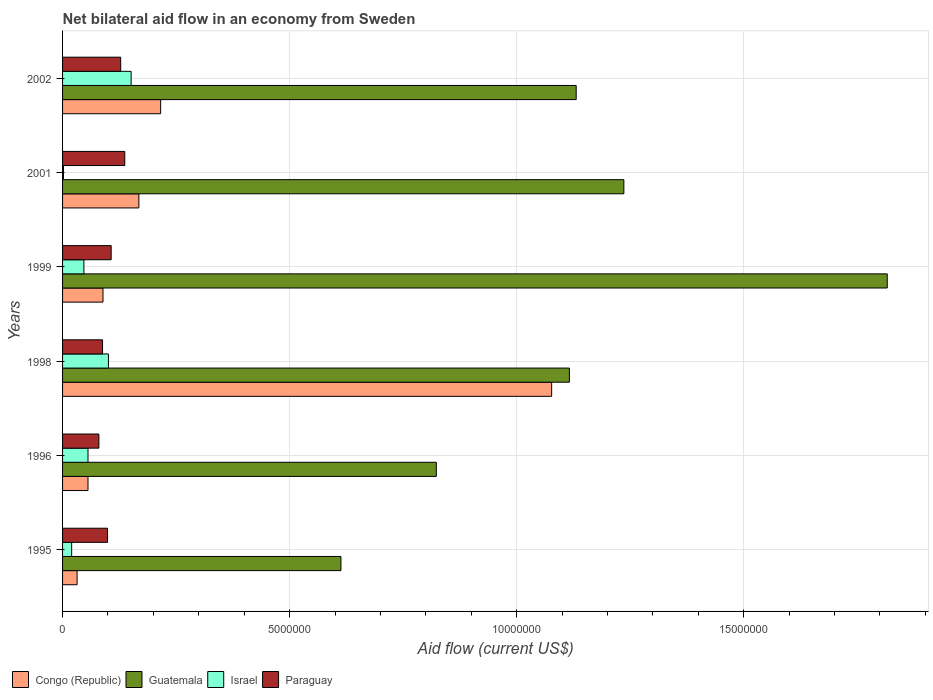How many different coloured bars are there?
Offer a terse response. 4. How many groups of bars are there?
Provide a succinct answer. 6. Are the number of bars per tick equal to the number of legend labels?
Offer a very short reply. Yes. How many bars are there on the 2nd tick from the top?
Offer a terse response. 4. What is the label of the 4th group of bars from the top?
Ensure brevity in your answer.  1998. What is the net bilateral aid flow in Guatemala in 2002?
Your answer should be compact. 1.13e+07. Across all years, what is the maximum net bilateral aid flow in Israel?
Provide a succinct answer. 1.51e+06. Across all years, what is the minimum net bilateral aid flow in Guatemala?
Your answer should be compact. 6.13e+06. In which year was the net bilateral aid flow in Guatemala minimum?
Your answer should be very brief. 1995. What is the total net bilateral aid flow in Guatemala in the graph?
Ensure brevity in your answer.  6.74e+07. What is the difference between the net bilateral aid flow in Paraguay in 1995 and that in 1999?
Your response must be concise. -8.00e+04. What is the difference between the net bilateral aid flow in Israel in 2001 and the net bilateral aid flow in Paraguay in 2002?
Make the answer very short. -1.26e+06. What is the average net bilateral aid flow in Paraguay per year?
Provide a succinct answer. 1.06e+06. In the year 1996, what is the difference between the net bilateral aid flow in Congo (Republic) and net bilateral aid flow in Guatemala?
Ensure brevity in your answer.  -7.67e+06. In how many years, is the net bilateral aid flow in Guatemala greater than 2000000 US$?
Provide a short and direct response. 6. What is the ratio of the net bilateral aid flow in Paraguay in 1998 to that in 2002?
Offer a terse response. 0.69. What is the difference between the highest and the second highest net bilateral aid flow in Paraguay?
Your answer should be very brief. 9.00e+04. What is the difference between the highest and the lowest net bilateral aid flow in Congo (Republic)?
Ensure brevity in your answer.  1.04e+07. In how many years, is the net bilateral aid flow in Israel greater than the average net bilateral aid flow in Israel taken over all years?
Your response must be concise. 2. Is the sum of the net bilateral aid flow in Paraguay in 1998 and 2002 greater than the maximum net bilateral aid flow in Congo (Republic) across all years?
Make the answer very short. No. What does the 4th bar from the top in 2002 represents?
Give a very brief answer. Congo (Republic). Are all the bars in the graph horizontal?
Provide a succinct answer. Yes. How many years are there in the graph?
Give a very brief answer. 6. What is the difference between two consecutive major ticks on the X-axis?
Provide a succinct answer. 5.00e+06. How many legend labels are there?
Make the answer very short. 4. How are the legend labels stacked?
Offer a terse response. Horizontal. What is the title of the graph?
Make the answer very short. Net bilateral aid flow in an economy from Sweden. Does "Puerto Rico" appear as one of the legend labels in the graph?
Offer a terse response. No. What is the label or title of the X-axis?
Offer a terse response. Aid flow (current US$). What is the label or title of the Y-axis?
Make the answer very short. Years. What is the Aid flow (current US$) in Guatemala in 1995?
Provide a succinct answer. 6.13e+06. What is the Aid flow (current US$) in Israel in 1995?
Keep it short and to the point. 2.00e+05. What is the Aid flow (current US$) in Paraguay in 1995?
Ensure brevity in your answer.  9.90e+05. What is the Aid flow (current US$) of Congo (Republic) in 1996?
Your response must be concise. 5.60e+05. What is the Aid flow (current US$) of Guatemala in 1996?
Your response must be concise. 8.23e+06. What is the Aid flow (current US$) in Israel in 1996?
Provide a short and direct response. 5.60e+05. What is the Aid flow (current US$) of Congo (Republic) in 1998?
Offer a terse response. 1.08e+07. What is the Aid flow (current US$) of Guatemala in 1998?
Make the answer very short. 1.12e+07. What is the Aid flow (current US$) in Israel in 1998?
Give a very brief answer. 1.01e+06. What is the Aid flow (current US$) in Paraguay in 1998?
Give a very brief answer. 8.80e+05. What is the Aid flow (current US$) in Congo (Republic) in 1999?
Keep it short and to the point. 8.90e+05. What is the Aid flow (current US$) in Guatemala in 1999?
Your response must be concise. 1.82e+07. What is the Aid flow (current US$) in Paraguay in 1999?
Offer a terse response. 1.07e+06. What is the Aid flow (current US$) in Congo (Republic) in 2001?
Ensure brevity in your answer.  1.68e+06. What is the Aid flow (current US$) of Guatemala in 2001?
Give a very brief answer. 1.24e+07. What is the Aid flow (current US$) in Paraguay in 2001?
Your response must be concise. 1.37e+06. What is the Aid flow (current US$) of Congo (Republic) in 2002?
Your response must be concise. 2.16e+06. What is the Aid flow (current US$) of Guatemala in 2002?
Your answer should be compact. 1.13e+07. What is the Aid flow (current US$) in Israel in 2002?
Your answer should be very brief. 1.51e+06. What is the Aid flow (current US$) of Paraguay in 2002?
Give a very brief answer. 1.28e+06. Across all years, what is the maximum Aid flow (current US$) in Congo (Republic)?
Provide a short and direct response. 1.08e+07. Across all years, what is the maximum Aid flow (current US$) of Guatemala?
Give a very brief answer. 1.82e+07. Across all years, what is the maximum Aid flow (current US$) in Israel?
Offer a terse response. 1.51e+06. Across all years, what is the maximum Aid flow (current US$) of Paraguay?
Provide a short and direct response. 1.37e+06. Across all years, what is the minimum Aid flow (current US$) in Congo (Republic)?
Give a very brief answer. 3.20e+05. Across all years, what is the minimum Aid flow (current US$) of Guatemala?
Your answer should be very brief. 6.13e+06. Across all years, what is the minimum Aid flow (current US$) of Israel?
Make the answer very short. 2.00e+04. What is the total Aid flow (current US$) in Congo (Republic) in the graph?
Give a very brief answer. 1.64e+07. What is the total Aid flow (current US$) of Guatemala in the graph?
Provide a short and direct response. 6.74e+07. What is the total Aid flow (current US$) in Israel in the graph?
Provide a short and direct response. 3.77e+06. What is the total Aid flow (current US$) in Paraguay in the graph?
Give a very brief answer. 6.39e+06. What is the difference between the Aid flow (current US$) in Guatemala in 1995 and that in 1996?
Provide a succinct answer. -2.10e+06. What is the difference between the Aid flow (current US$) in Israel in 1995 and that in 1996?
Offer a terse response. -3.60e+05. What is the difference between the Aid flow (current US$) in Congo (Republic) in 1995 and that in 1998?
Your response must be concise. -1.04e+07. What is the difference between the Aid flow (current US$) of Guatemala in 1995 and that in 1998?
Ensure brevity in your answer.  -5.03e+06. What is the difference between the Aid flow (current US$) of Israel in 1995 and that in 1998?
Make the answer very short. -8.10e+05. What is the difference between the Aid flow (current US$) of Congo (Republic) in 1995 and that in 1999?
Offer a very short reply. -5.70e+05. What is the difference between the Aid flow (current US$) in Guatemala in 1995 and that in 1999?
Give a very brief answer. -1.20e+07. What is the difference between the Aid flow (current US$) of Israel in 1995 and that in 1999?
Your response must be concise. -2.70e+05. What is the difference between the Aid flow (current US$) of Paraguay in 1995 and that in 1999?
Provide a short and direct response. -8.00e+04. What is the difference between the Aid flow (current US$) in Congo (Republic) in 1995 and that in 2001?
Keep it short and to the point. -1.36e+06. What is the difference between the Aid flow (current US$) of Guatemala in 1995 and that in 2001?
Your answer should be very brief. -6.23e+06. What is the difference between the Aid flow (current US$) of Paraguay in 1995 and that in 2001?
Offer a terse response. -3.80e+05. What is the difference between the Aid flow (current US$) of Congo (Republic) in 1995 and that in 2002?
Your answer should be compact. -1.84e+06. What is the difference between the Aid flow (current US$) of Guatemala in 1995 and that in 2002?
Offer a terse response. -5.18e+06. What is the difference between the Aid flow (current US$) in Israel in 1995 and that in 2002?
Make the answer very short. -1.31e+06. What is the difference between the Aid flow (current US$) of Congo (Republic) in 1996 and that in 1998?
Offer a very short reply. -1.02e+07. What is the difference between the Aid flow (current US$) of Guatemala in 1996 and that in 1998?
Keep it short and to the point. -2.93e+06. What is the difference between the Aid flow (current US$) of Israel in 1996 and that in 1998?
Offer a terse response. -4.50e+05. What is the difference between the Aid flow (current US$) of Congo (Republic) in 1996 and that in 1999?
Give a very brief answer. -3.30e+05. What is the difference between the Aid flow (current US$) in Guatemala in 1996 and that in 1999?
Keep it short and to the point. -9.93e+06. What is the difference between the Aid flow (current US$) in Paraguay in 1996 and that in 1999?
Give a very brief answer. -2.70e+05. What is the difference between the Aid flow (current US$) of Congo (Republic) in 1996 and that in 2001?
Give a very brief answer. -1.12e+06. What is the difference between the Aid flow (current US$) in Guatemala in 1996 and that in 2001?
Your response must be concise. -4.13e+06. What is the difference between the Aid flow (current US$) of Israel in 1996 and that in 2001?
Your response must be concise. 5.40e+05. What is the difference between the Aid flow (current US$) of Paraguay in 1996 and that in 2001?
Ensure brevity in your answer.  -5.70e+05. What is the difference between the Aid flow (current US$) in Congo (Republic) in 1996 and that in 2002?
Make the answer very short. -1.60e+06. What is the difference between the Aid flow (current US$) in Guatemala in 1996 and that in 2002?
Your answer should be compact. -3.08e+06. What is the difference between the Aid flow (current US$) in Israel in 1996 and that in 2002?
Make the answer very short. -9.50e+05. What is the difference between the Aid flow (current US$) of Paraguay in 1996 and that in 2002?
Offer a very short reply. -4.80e+05. What is the difference between the Aid flow (current US$) in Congo (Republic) in 1998 and that in 1999?
Give a very brief answer. 9.88e+06. What is the difference between the Aid flow (current US$) of Guatemala in 1998 and that in 1999?
Ensure brevity in your answer.  -7.00e+06. What is the difference between the Aid flow (current US$) of Israel in 1998 and that in 1999?
Your response must be concise. 5.40e+05. What is the difference between the Aid flow (current US$) in Congo (Republic) in 1998 and that in 2001?
Make the answer very short. 9.09e+06. What is the difference between the Aid flow (current US$) of Guatemala in 1998 and that in 2001?
Ensure brevity in your answer.  -1.20e+06. What is the difference between the Aid flow (current US$) in Israel in 1998 and that in 2001?
Provide a succinct answer. 9.90e+05. What is the difference between the Aid flow (current US$) of Paraguay in 1998 and that in 2001?
Your response must be concise. -4.90e+05. What is the difference between the Aid flow (current US$) in Congo (Republic) in 1998 and that in 2002?
Provide a short and direct response. 8.61e+06. What is the difference between the Aid flow (current US$) of Israel in 1998 and that in 2002?
Offer a terse response. -5.00e+05. What is the difference between the Aid flow (current US$) in Paraguay in 1998 and that in 2002?
Offer a very short reply. -4.00e+05. What is the difference between the Aid flow (current US$) in Congo (Republic) in 1999 and that in 2001?
Offer a very short reply. -7.90e+05. What is the difference between the Aid flow (current US$) of Guatemala in 1999 and that in 2001?
Provide a short and direct response. 5.80e+06. What is the difference between the Aid flow (current US$) of Paraguay in 1999 and that in 2001?
Your answer should be very brief. -3.00e+05. What is the difference between the Aid flow (current US$) of Congo (Republic) in 1999 and that in 2002?
Keep it short and to the point. -1.27e+06. What is the difference between the Aid flow (current US$) in Guatemala in 1999 and that in 2002?
Provide a succinct answer. 6.85e+06. What is the difference between the Aid flow (current US$) in Israel in 1999 and that in 2002?
Your response must be concise. -1.04e+06. What is the difference between the Aid flow (current US$) in Paraguay in 1999 and that in 2002?
Offer a terse response. -2.10e+05. What is the difference between the Aid flow (current US$) in Congo (Republic) in 2001 and that in 2002?
Your response must be concise. -4.80e+05. What is the difference between the Aid flow (current US$) of Guatemala in 2001 and that in 2002?
Provide a short and direct response. 1.05e+06. What is the difference between the Aid flow (current US$) in Israel in 2001 and that in 2002?
Offer a very short reply. -1.49e+06. What is the difference between the Aid flow (current US$) of Paraguay in 2001 and that in 2002?
Keep it short and to the point. 9.00e+04. What is the difference between the Aid flow (current US$) of Congo (Republic) in 1995 and the Aid flow (current US$) of Guatemala in 1996?
Your response must be concise. -7.91e+06. What is the difference between the Aid flow (current US$) in Congo (Republic) in 1995 and the Aid flow (current US$) in Paraguay in 1996?
Your answer should be compact. -4.80e+05. What is the difference between the Aid flow (current US$) of Guatemala in 1995 and the Aid flow (current US$) of Israel in 1996?
Give a very brief answer. 5.57e+06. What is the difference between the Aid flow (current US$) in Guatemala in 1995 and the Aid flow (current US$) in Paraguay in 1996?
Offer a very short reply. 5.33e+06. What is the difference between the Aid flow (current US$) of Israel in 1995 and the Aid flow (current US$) of Paraguay in 1996?
Your answer should be compact. -6.00e+05. What is the difference between the Aid flow (current US$) of Congo (Republic) in 1995 and the Aid flow (current US$) of Guatemala in 1998?
Your response must be concise. -1.08e+07. What is the difference between the Aid flow (current US$) in Congo (Republic) in 1995 and the Aid flow (current US$) in Israel in 1998?
Your answer should be compact. -6.90e+05. What is the difference between the Aid flow (current US$) in Congo (Republic) in 1995 and the Aid flow (current US$) in Paraguay in 1998?
Offer a terse response. -5.60e+05. What is the difference between the Aid flow (current US$) in Guatemala in 1995 and the Aid flow (current US$) in Israel in 1998?
Make the answer very short. 5.12e+06. What is the difference between the Aid flow (current US$) of Guatemala in 1995 and the Aid flow (current US$) of Paraguay in 1998?
Your answer should be compact. 5.25e+06. What is the difference between the Aid flow (current US$) of Israel in 1995 and the Aid flow (current US$) of Paraguay in 1998?
Give a very brief answer. -6.80e+05. What is the difference between the Aid flow (current US$) in Congo (Republic) in 1995 and the Aid flow (current US$) in Guatemala in 1999?
Your response must be concise. -1.78e+07. What is the difference between the Aid flow (current US$) of Congo (Republic) in 1995 and the Aid flow (current US$) of Israel in 1999?
Your response must be concise. -1.50e+05. What is the difference between the Aid flow (current US$) of Congo (Republic) in 1995 and the Aid flow (current US$) of Paraguay in 1999?
Offer a very short reply. -7.50e+05. What is the difference between the Aid flow (current US$) of Guatemala in 1995 and the Aid flow (current US$) of Israel in 1999?
Make the answer very short. 5.66e+06. What is the difference between the Aid flow (current US$) of Guatemala in 1995 and the Aid flow (current US$) of Paraguay in 1999?
Keep it short and to the point. 5.06e+06. What is the difference between the Aid flow (current US$) of Israel in 1995 and the Aid flow (current US$) of Paraguay in 1999?
Your answer should be compact. -8.70e+05. What is the difference between the Aid flow (current US$) of Congo (Republic) in 1995 and the Aid flow (current US$) of Guatemala in 2001?
Offer a very short reply. -1.20e+07. What is the difference between the Aid flow (current US$) in Congo (Republic) in 1995 and the Aid flow (current US$) in Paraguay in 2001?
Make the answer very short. -1.05e+06. What is the difference between the Aid flow (current US$) in Guatemala in 1995 and the Aid flow (current US$) in Israel in 2001?
Your answer should be very brief. 6.11e+06. What is the difference between the Aid flow (current US$) in Guatemala in 1995 and the Aid flow (current US$) in Paraguay in 2001?
Your answer should be compact. 4.76e+06. What is the difference between the Aid flow (current US$) of Israel in 1995 and the Aid flow (current US$) of Paraguay in 2001?
Provide a succinct answer. -1.17e+06. What is the difference between the Aid flow (current US$) in Congo (Republic) in 1995 and the Aid flow (current US$) in Guatemala in 2002?
Give a very brief answer. -1.10e+07. What is the difference between the Aid flow (current US$) in Congo (Republic) in 1995 and the Aid flow (current US$) in Israel in 2002?
Offer a very short reply. -1.19e+06. What is the difference between the Aid flow (current US$) in Congo (Republic) in 1995 and the Aid flow (current US$) in Paraguay in 2002?
Give a very brief answer. -9.60e+05. What is the difference between the Aid flow (current US$) in Guatemala in 1995 and the Aid flow (current US$) in Israel in 2002?
Offer a terse response. 4.62e+06. What is the difference between the Aid flow (current US$) of Guatemala in 1995 and the Aid flow (current US$) of Paraguay in 2002?
Your answer should be compact. 4.85e+06. What is the difference between the Aid flow (current US$) in Israel in 1995 and the Aid flow (current US$) in Paraguay in 2002?
Provide a short and direct response. -1.08e+06. What is the difference between the Aid flow (current US$) in Congo (Republic) in 1996 and the Aid flow (current US$) in Guatemala in 1998?
Make the answer very short. -1.06e+07. What is the difference between the Aid flow (current US$) of Congo (Republic) in 1996 and the Aid flow (current US$) of Israel in 1998?
Provide a short and direct response. -4.50e+05. What is the difference between the Aid flow (current US$) of Congo (Republic) in 1996 and the Aid flow (current US$) of Paraguay in 1998?
Your response must be concise. -3.20e+05. What is the difference between the Aid flow (current US$) of Guatemala in 1996 and the Aid flow (current US$) of Israel in 1998?
Keep it short and to the point. 7.22e+06. What is the difference between the Aid flow (current US$) of Guatemala in 1996 and the Aid flow (current US$) of Paraguay in 1998?
Give a very brief answer. 7.35e+06. What is the difference between the Aid flow (current US$) in Israel in 1996 and the Aid flow (current US$) in Paraguay in 1998?
Your response must be concise. -3.20e+05. What is the difference between the Aid flow (current US$) in Congo (Republic) in 1996 and the Aid flow (current US$) in Guatemala in 1999?
Give a very brief answer. -1.76e+07. What is the difference between the Aid flow (current US$) in Congo (Republic) in 1996 and the Aid flow (current US$) in Paraguay in 1999?
Provide a short and direct response. -5.10e+05. What is the difference between the Aid flow (current US$) of Guatemala in 1996 and the Aid flow (current US$) of Israel in 1999?
Keep it short and to the point. 7.76e+06. What is the difference between the Aid flow (current US$) of Guatemala in 1996 and the Aid flow (current US$) of Paraguay in 1999?
Your response must be concise. 7.16e+06. What is the difference between the Aid flow (current US$) of Israel in 1996 and the Aid flow (current US$) of Paraguay in 1999?
Make the answer very short. -5.10e+05. What is the difference between the Aid flow (current US$) of Congo (Republic) in 1996 and the Aid flow (current US$) of Guatemala in 2001?
Make the answer very short. -1.18e+07. What is the difference between the Aid flow (current US$) of Congo (Republic) in 1996 and the Aid flow (current US$) of Israel in 2001?
Offer a terse response. 5.40e+05. What is the difference between the Aid flow (current US$) in Congo (Republic) in 1996 and the Aid flow (current US$) in Paraguay in 2001?
Give a very brief answer. -8.10e+05. What is the difference between the Aid flow (current US$) of Guatemala in 1996 and the Aid flow (current US$) of Israel in 2001?
Provide a short and direct response. 8.21e+06. What is the difference between the Aid flow (current US$) of Guatemala in 1996 and the Aid flow (current US$) of Paraguay in 2001?
Provide a succinct answer. 6.86e+06. What is the difference between the Aid flow (current US$) of Israel in 1996 and the Aid flow (current US$) of Paraguay in 2001?
Your response must be concise. -8.10e+05. What is the difference between the Aid flow (current US$) of Congo (Republic) in 1996 and the Aid flow (current US$) of Guatemala in 2002?
Provide a short and direct response. -1.08e+07. What is the difference between the Aid flow (current US$) in Congo (Republic) in 1996 and the Aid flow (current US$) in Israel in 2002?
Provide a succinct answer. -9.50e+05. What is the difference between the Aid flow (current US$) of Congo (Republic) in 1996 and the Aid flow (current US$) of Paraguay in 2002?
Provide a short and direct response. -7.20e+05. What is the difference between the Aid flow (current US$) of Guatemala in 1996 and the Aid flow (current US$) of Israel in 2002?
Provide a succinct answer. 6.72e+06. What is the difference between the Aid flow (current US$) of Guatemala in 1996 and the Aid flow (current US$) of Paraguay in 2002?
Give a very brief answer. 6.95e+06. What is the difference between the Aid flow (current US$) in Israel in 1996 and the Aid flow (current US$) in Paraguay in 2002?
Offer a very short reply. -7.20e+05. What is the difference between the Aid flow (current US$) in Congo (Republic) in 1998 and the Aid flow (current US$) in Guatemala in 1999?
Your response must be concise. -7.39e+06. What is the difference between the Aid flow (current US$) in Congo (Republic) in 1998 and the Aid flow (current US$) in Israel in 1999?
Provide a short and direct response. 1.03e+07. What is the difference between the Aid flow (current US$) in Congo (Republic) in 1998 and the Aid flow (current US$) in Paraguay in 1999?
Your answer should be compact. 9.70e+06. What is the difference between the Aid flow (current US$) of Guatemala in 1998 and the Aid flow (current US$) of Israel in 1999?
Provide a succinct answer. 1.07e+07. What is the difference between the Aid flow (current US$) of Guatemala in 1998 and the Aid flow (current US$) of Paraguay in 1999?
Your response must be concise. 1.01e+07. What is the difference between the Aid flow (current US$) of Congo (Republic) in 1998 and the Aid flow (current US$) of Guatemala in 2001?
Provide a short and direct response. -1.59e+06. What is the difference between the Aid flow (current US$) in Congo (Republic) in 1998 and the Aid flow (current US$) in Israel in 2001?
Your response must be concise. 1.08e+07. What is the difference between the Aid flow (current US$) of Congo (Republic) in 1998 and the Aid flow (current US$) of Paraguay in 2001?
Your response must be concise. 9.40e+06. What is the difference between the Aid flow (current US$) of Guatemala in 1998 and the Aid flow (current US$) of Israel in 2001?
Ensure brevity in your answer.  1.11e+07. What is the difference between the Aid flow (current US$) in Guatemala in 1998 and the Aid flow (current US$) in Paraguay in 2001?
Give a very brief answer. 9.79e+06. What is the difference between the Aid flow (current US$) in Israel in 1998 and the Aid flow (current US$) in Paraguay in 2001?
Offer a terse response. -3.60e+05. What is the difference between the Aid flow (current US$) in Congo (Republic) in 1998 and the Aid flow (current US$) in Guatemala in 2002?
Ensure brevity in your answer.  -5.40e+05. What is the difference between the Aid flow (current US$) in Congo (Republic) in 1998 and the Aid flow (current US$) in Israel in 2002?
Your answer should be compact. 9.26e+06. What is the difference between the Aid flow (current US$) of Congo (Republic) in 1998 and the Aid flow (current US$) of Paraguay in 2002?
Provide a succinct answer. 9.49e+06. What is the difference between the Aid flow (current US$) of Guatemala in 1998 and the Aid flow (current US$) of Israel in 2002?
Provide a short and direct response. 9.65e+06. What is the difference between the Aid flow (current US$) in Guatemala in 1998 and the Aid flow (current US$) in Paraguay in 2002?
Offer a terse response. 9.88e+06. What is the difference between the Aid flow (current US$) of Congo (Republic) in 1999 and the Aid flow (current US$) of Guatemala in 2001?
Offer a terse response. -1.15e+07. What is the difference between the Aid flow (current US$) of Congo (Republic) in 1999 and the Aid flow (current US$) of Israel in 2001?
Offer a terse response. 8.70e+05. What is the difference between the Aid flow (current US$) in Congo (Republic) in 1999 and the Aid flow (current US$) in Paraguay in 2001?
Provide a short and direct response. -4.80e+05. What is the difference between the Aid flow (current US$) of Guatemala in 1999 and the Aid flow (current US$) of Israel in 2001?
Give a very brief answer. 1.81e+07. What is the difference between the Aid flow (current US$) of Guatemala in 1999 and the Aid flow (current US$) of Paraguay in 2001?
Provide a short and direct response. 1.68e+07. What is the difference between the Aid flow (current US$) in Israel in 1999 and the Aid flow (current US$) in Paraguay in 2001?
Provide a succinct answer. -9.00e+05. What is the difference between the Aid flow (current US$) in Congo (Republic) in 1999 and the Aid flow (current US$) in Guatemala in 2002?
Offer a terse response. -1.04e+07. What is the difference between the Aid flow (current US$) in Congo (Republic) in 1999 and the Aid flow (current US$) in Israel in 2002?
Make the answer very short. -6.20e+05. What is the difference between the Aid flow (current US$) of Congo (Republic) in 1999 and the Aid flow (current US$) of Paraguay in 2002?
Provide a succinct answer. -3.90e+05. What is the difference between the Aid flow (current US$) in Guatemala in 1999 and the Aid flow (current US$) in Israel in 2002?
Your response must be concise. 1.66e+07. What is the difference between the Aid flow (current US$) of Guatemala in 1999 and the Aid flow (current US$) of Paraguay in 2002?
Keep it short and to the point. 1.69e+07. What is the difference between the Aid flow (current US$) of Israel in 1999 and the Aid flow (current US$) of Paraguay in 2002?
Provide a short and direct response. -8.10e+05. What is the difference between the Aid flow (current US$) in Congo (Republic) in 2001 and the Aid flow (current US$) in Guatemala in 2002?
Make the answer very short. -9.63e+06. What is the difference between the Aid flow (current US$) of Guatemala in 2001 and the Aid flow (current US$) of Israel in 2002?
Ensure brevity in your answer.  1.08e+07. What is the difference between the Aid flow (current US$) of Guatemala in 2001 and the Aid flow (current US$) of Paraguay in 2002?
Offer a very short reply. 1.11e+07. What is the difference between the Aid flow (current US$) of Israel in 2001 and the Aid flow (current US$) of Paraguay in 2002?
Ensure brevity in your answer.  -1.26e+06. What is the average Aid flow (current US$) of Congo (Republic) per year?
Provide a succinct answer. 2.73e+06. What is the average Aid flow (current US$) in Guatemala per year?
Offer a very short reply. 1.12e+07. What is the average Aid flow (current US$) in Israel per year?
Provide a succinct answer. 6.28e+05. What is the average Aid flow (current US$) of Paraguay per year?
Give a very brief answer. 1.06e+06. In the year 1995, what is the difference between the Aid flow (current US$) of Congo (Republic) and Aid flow (current US$) of Guatemala?
Your response must be concise. -5.81e+06. In the year 1995, what is the difference between the Aid flow (current US$) of Congo (Republic) and Aid flow (current US$) of Israel?
Provide a succinct answer. 1.20e+05. In the year 1995, what is the difference between the Aid flow (current US$) of Congo (Republic) and Aid flow (current US$) of Paraguay?
Provide a succinct answer. -6.70e+05. In the year 1995, what is the difference between the Aid flow (current US$) of Guatemala and Aid flow (current US$) of Israel?
Your response must be concise. 5.93e+06. In the year 1995, what is the difference between the Aid flow (current US$) in Guatemala and Aid flow (current US$) in Paraguay?
Make the answer very short. 5.14e+06. In the year 1995, what is the difference between the Aid flow (current US$) in Israel and Aid flow (current US$) in Paraguay?
Your answer should be very brief. -7.90e+05. In the year 1996, what is the difference between the Aid flow (current US$) in Congo (Republic) and Aid flow (current US$) in Guatemala?
Provide a succinct answer. -7.67e+06. In the year 1996, what is the difference between the Aid flow (current US$) in Guatemala and Aid flow (current US$) in Israel?
Offer a terse response. 7.67e+06. In the year 1996, what is the difference between the Aid flow (current US$) in Guatemala and Aid flow (current US$) in Paraguay?
Your answer should be compact. 7.43e+06. In the year 1996, what is the difference between the Aid flow (current US$) of Israel and Aid flow (current US$) of Paraguay?
Make the answer very short. -2.40e+05. In the year 1998, what is the difference between the Aid flow (current US$) of Congo (Republic) and Aid flow (current US$) of Guatemala?
Offer a very short reply. -3.90e+05. In the year 1998, what is the difference between the Aid flow (current US$) of Congo (Republic) and Aid flow (current US$) of Israel?
Provide a short and direct response. 9.76e+06. In the year 1998, what is the difference between the Aid flow (current US$) in Congo (Republic) and Aid flow (current US$) in Paraguay?
Offer a very short reply. 9.89e+06. In the year 1998, what is the difference between the Aid flow (current US$) of Guatemala and Aid flow (current US$) of Israel?
Your answer should be compact. 1.02e+07. In the year 1998, what is the difference between the Aid flow (current US$) in Guatemala and Aid flow (current US$) in Paraguay?
Offer a very short reply. 1.03e+07. In the year 1999, what is the difference between the Aid flow (current US$) of Congo (Republic) and Aid flow (current US$) of Guatemala?
Ensure brevity in your answer.  -1.73e+07. In the year 1999, what is the difference between the Aid flow (current US$) in Congo (Republic) and Aid flow (current US$) in Paraguay?
Offer a terse response. -1.80e+05. In the year 1999, what is the difference between the Aid flow (current US$) in Guatemala and Aid flow (current US$) in Israel?
Offer a very short reply. 1.77e+07. In the year 1999, what is the difference between the Aid flow (current US$) in Guatemala and Aid flow (current US$) in Paraguay?
Provide a short and direct response. 1.71e+07. In the year 1999, what is the difference between the Aid flow (current US$) in Israel and Aid flow (current US$) in Paraguay?
Offer a terse response. -6.00e+05. In the year 2001, what is the difference between the Aid flow (current US$) in Congo (Republic) and Aid flow (current US$) in Guatemala?
Offer a very short reply. -1.07e+07. In the year 2001, what is the difference between the Aid flow (current US$) of Congo (Republic) and Aid flow (current US$) of Israel?
Ensure brevity in your answer.  1.66e+06. In the year 2001, what is the difference between the Aid flow (current US$) of Guatemala and Aid flow (current US$) of Israel?
Offer a terse response. 1.23e+07. In the year 2001, what is the difference between the Aid flow (current US$) in Guatemala and Aid flow (current US$) in Paraguay?
Provide a short and direct response. 1.10e+07. In the year 2001, what is the difference between the Aid flow (current US$) of Israel and Aid flow (current US$) of Paraguay?
Offer a terse response. -1.35e+06. In the year 2002, what is the difference between the Aid flow (current US$) in Congo (Republic) and Aid flow (current US$) in Guatemala?
Keep it short and to the point. -9.15e+06. In the year 2002, what is the difference between the Aid flow (current US$) of Congo (Republic) and Aid flow (current US$) of Israel?
Offer a terse response. 6.50e+05. In the year 2002, what is the difference between the Aid flow (current US$) in Congo (Republic) and Aid flow (current US$) in Paraguay?
Offer a very short reply. 8.80e+05. In the year 2002, what is the difference between the Aid flow (current US$) in Guatemala and Aid flow (current US$) in Israel?
Your answer should be very brief. 9.80e+06. In the year 2002, what is the difference between the Aid flow (current US$) of Guatemala and Aid flow (current US$) of Paraguay?
Give a very brief answer. 1.00e+07. What is the ratio of the Aid flow (current US$) of Guatemala in 1995 to that in 1996?
Offer a terse response. 0.74. What is the ratio of the Aid flow (current US$) of Israel in 1995 to that in 1996?
Your answer should be compact. 0.36. What is the ratio of the Aid flow (current US$) in Paraguay in 1995 to that in 1996?
Provide a short and direct response. 1.24. What is the ratio of the Aid flow (current US$) in Congo (Republic) in 1995 to that in 1998?
Your answer should be compact. 0.03. What is the ratio of the Aid flow (current US$) of Guatemala in 1995 to that in 1998?
Provide a short and direct response. 0.55. What is the ratio of the Aid flow (current US$) of Israel in 1995 to that in 1998?
Provide a short and direct response. 0.2. What is the ratio of the Aid flow (current US$) in Paraguay in 1995 to that in 1998?
Keep it short and to the point. 1.12. What is the ratio of the Aid flow (current US$) in Congo (Republic) in 1995 to that in 1999?
Your answer should be compact. 0.36. What is the ratio of the Aid flow (current US$) in Guatemala in 1995 to that in 1999?
Your answer should be very brief. 0.34. What is the ratio of the Aid flow (current US$) of Israel in 1995 to that in 1999?
Keep it short and to the point. 0.43. What is the ratio of the Aid flow (current US$) in Paraguay in 1995 to that in 1999?
Keep it short and to the point. 0.93. What is the ratio of the Aid flow (current US$) of Congo (Republic) in 1995 to that in 2001?
Ensure brevity in your answer.  0.19. What is the ratio of the Aid flow (current US$) of Guatemala in 1995 to that in 2001?
Your answer should be very brief. 0.5. What is the ratio of the Aid flow (current US$) of Israel in 1995 to that in 2001?
Your answer should be compact. 10. What is the ratio of the Aid flow (current US$) of Paraguay in 1995 to that in 2001?
Offer a terse response. 0.72. What is the ratio of the Aid flow (current US$) in Congo (Republic) in 1995 to that in 2002?
Offer a very short reply. 0.15. What is the ratio of the Aid flow (current US$) of Guatemala in 1995 to that in 2002?
Your answer should be very brief. 0.54. What is the ratio of the Aid flow (current US$) in Israel in 1995 to that in 2002?
Your response must be concise. 0.13. What is the ratio of the Aid flow (current US$) in Paraguay in 1995 to that in 2002?
Your response must be concise. 0.77. What is the ratio of the Aid flow (current US$) of Congo (Republic) in 1996 to that in 1998?
Your answer should be very brief. 0.05. What is the ratio of the Aid flow (current US$) in Guatemala in 1996 to that in 1998?
Offer a very short reply. 0.74. What is the ratio of the Aid flow (current US$) in Israel in 1996 to that in 1998?
Offer a very short reply. 0.55. What is the ratio of the Aid flow (current US$) of Paraguay in 1996 to that in 1998?
Your response must be concise. 0.91. What is the ratio of the Aid flow (current US$) in Congo (Republic) in 1996 to that in 1999?
Offer a very short reply. 0.63. What is the ratio of the Aid flow (current US$) in Guatemala in 1996 to that in 1999?
Provide a short and direct response. 0.45. What is the ratio of the Aid flow (current US$) of Israel in 1996 to that in 1999?
Offer a terse response. 1.19. What is the ratio of the Aid flow (current US$) of Paraguay in 1996 to that in 1999?
Provide a succinct answer. 0.75. What is the ratio of the Aid flow (current US$) of Congo (Republic) in 1996 to that in 2001?
Provide a short and direct response. 0.33. What is the ratio of the Aid flow (current US$) of Guatemala in 1996 to that in 2001?
Give a very brief answer. 0.67. What is the ratio of the Aid flow (current US$) in Paraguay in 1996 to that in 2001?
Your answer should be very brief. 0.58. What is the ratio of the Aid flow (current US$) of Congo (Republic) in 1996 to that in 2002?
Provide a short and direct response. 0.26. What is the ratio of the Aid flow (current US$) in Guatemala in 1996 to that in 2002?
Provide a succinct answer. 0.73. What is the ratio of the Aid flow (current US$) in Israel in 1996 to that in 2002?
Ensure brevity in your answer.  0.37. What is the ratio of the Aid flow (current US$) in Congo (Republic) in 1998 to that in 1999?
Give a very brief answer. 12.1. What is the ratio of the Aid flow (current US$) in Guatemala in 1998 to that in 1999?
Your answer should be very brief. 0.61. What is the ratio of the Aid flow (current US$) of Israel in 1998 to that in 1999?
Make the answer very short. 2.15. What is the ratio of the Aid flow (current US$) in Paraguay in 1998 to that in 1999?
Your answer should be compact. 0.82. What is the ratio of the Aid flow (current US$) of Congo (Republic) in 1998 to that in 2001?
Ensure brevity in your answer.  6.41. What is the ratio of the Aid flow (current US$) of Guatemala in 1998 to that in 2001?
Keep it short and to the point. 0.9. What is the ratio of the Aid flow (current US$) in Israel in 1998 to that in 2001?
Your response must be concise. 50.5. What is the ratio of the Aid flow (current US$) of Paraguay in 1998 to that in 2001?
Provide a succinct answer. 0.64. What is the ratio of the Aid flow (current US$) of Congo (Republic) in 1998 to that in 2002?
Your answer should be compact. 4.99. What is the ratio of the Aid flow (current US$) in Guatemala in 1998 to that in 2002?
Your answer should be very brief. 0.99. What is the ratio of the Aid flow (current US$) in Israel in 1998 to that in 2002?
Ensure brevity in your answer.  0.67. What is the ratio of the Aid flow (current US$) in Paraguay in 1998 to that in 2002?
Your answer should be very brief. 0.69. What is the ratio of the Aid flow (current US$) of Congo (Republic) in 1999 to that in 2001?
Keep it short and to the point. 0.53. What is the ratio of the Aid flow (current US$) of Guatemala in 1999 to that in 2001?
Provide a succinct answer. 1.47. What is the ratio of the Aid flow (current US$) of Israel in 1999 to that in 2001?
Your answer should be compact. 23.5. What is the ratio of the Aid flow (current US$) in Paraguay in 1999 to that in 2001?
Give a very brief answer. 0.78. What is the ratio of the Aid flow (current US$) of Congo (Republic) in 1999 to that in 2002?
Provide a short and direct response. 0.41. What is the ratio of the Aid flow (current US$) in Guatemala in 1999 to that in 2002?
Your answer should be very brief. 1.61. What is the ratio of the Aid flow (current US$) in Israel in 1999 to that in 2002?
Make the answer very short. 0.31. What is the ratio of the Aid flow (current US$) of Paraguay in 1999 to that in 2002?
Provide a succinct answer. 0.84. What is the ratio of the Aid flow (current US$) of Guatemala in 2001 to that in 2002?
Give a very brief answer. 1.09. What is the ratio of the Aid flow (current US$) in Israel in 2001 to that in 2002?
Give a very brief answer. 0.01. What is the ratio of the Aid flow (current US$) in Paraguay in 2001 to that in 2002?
Keep it short and to the point. 1.07. What is the difference between the highest and the second highest Aid flow (current US$) in Congo (Republic)?
Give a very brief answer. 8.61e+06. What is the difference between the highest and the second highest Aid flow (current US$) of Guatemala?
Provide a short and direct response. 5.80e+06. What is the difference between the highest and the second highest Aid flow (current US$) of Paraguay?
Your answer should be very brief. 9.00e+04. What is the difference between the highest and the lowest Aid flow (current US$) of Congo (Republic)?
Keep it short and to the point. 1.04e+07. What is the difference between the highest and the lowest Aid flow (current US$) in Guatemala?
Offer a terse response. 1.20e+07. What is the difference between the highest and the lowest Aid flow (current US$) of Israel?
Keep it short and to the point. 1.49e+06. What is the difference between the highest and the lowest Aid flow (current US$) in Paraguay?
Your response must be concise. 5.70e+05. 